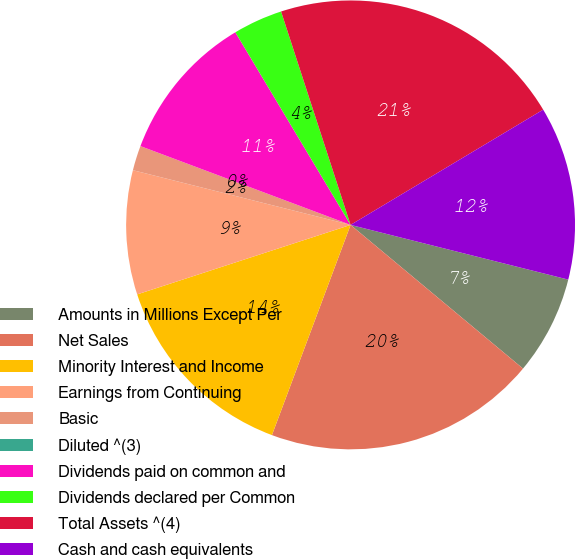Convert chart. <chart><loc_0><loc_0><loc_500><loc_500><pie_chart><fcel>Amounts in Millions Except Per<fcel>Net Sales<fcel>Minority Interest and Income<fcel>Earnings from Continuing<fcel>Basic<fcel>Diluted ^(3)<fcel>Dividends paid on common and<fcel>Dividends declared per Common<fcel>Total Assets ^(4)<fcel>Cash and cash equivalents<nl><fcel>7.14%<fcel>19.64%<fcel>14.29%<fcel>8.93%<fcel>1.79%<fcel>0.0%<fcel>10.71%<fcel>3.57%<fcel>21.43%<fcel>12.5%<nl></chart> 